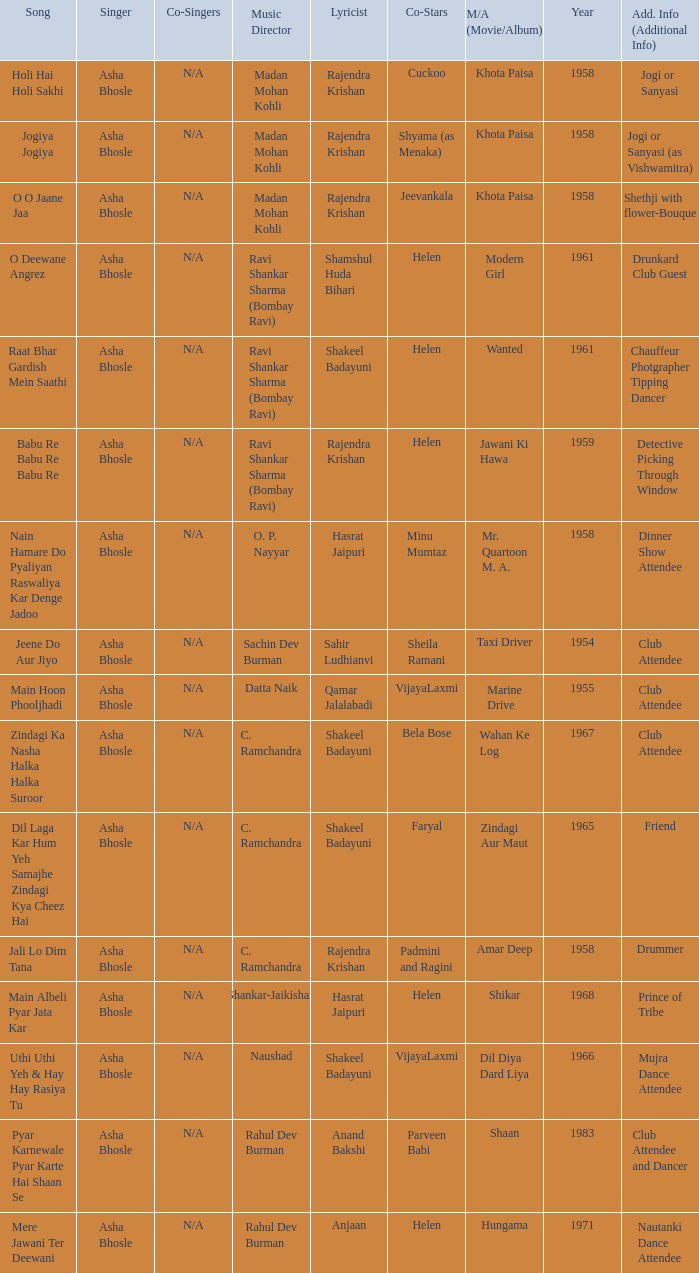What year did Naushad Direct the Music? 1966.0. 